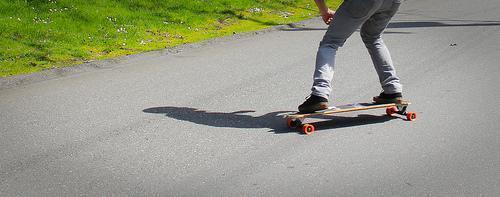How many persons skateboarding?
Give a very brief answer. 1. 